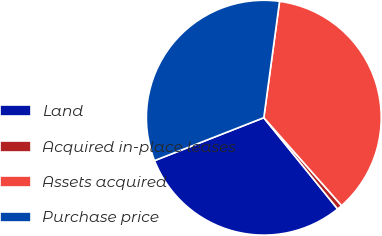Convert chart. <chart><loc_0><loc_0><loc_500><loc_500><pie_chart><fcel>Land<fcel>Acquired in-place leases<fcel>Assets acquired<fcel>Purchase price<nl><fcel>29.87%<fcel>0.7%<fcel>36.33%<fcel>33.1%<nl></chart> 